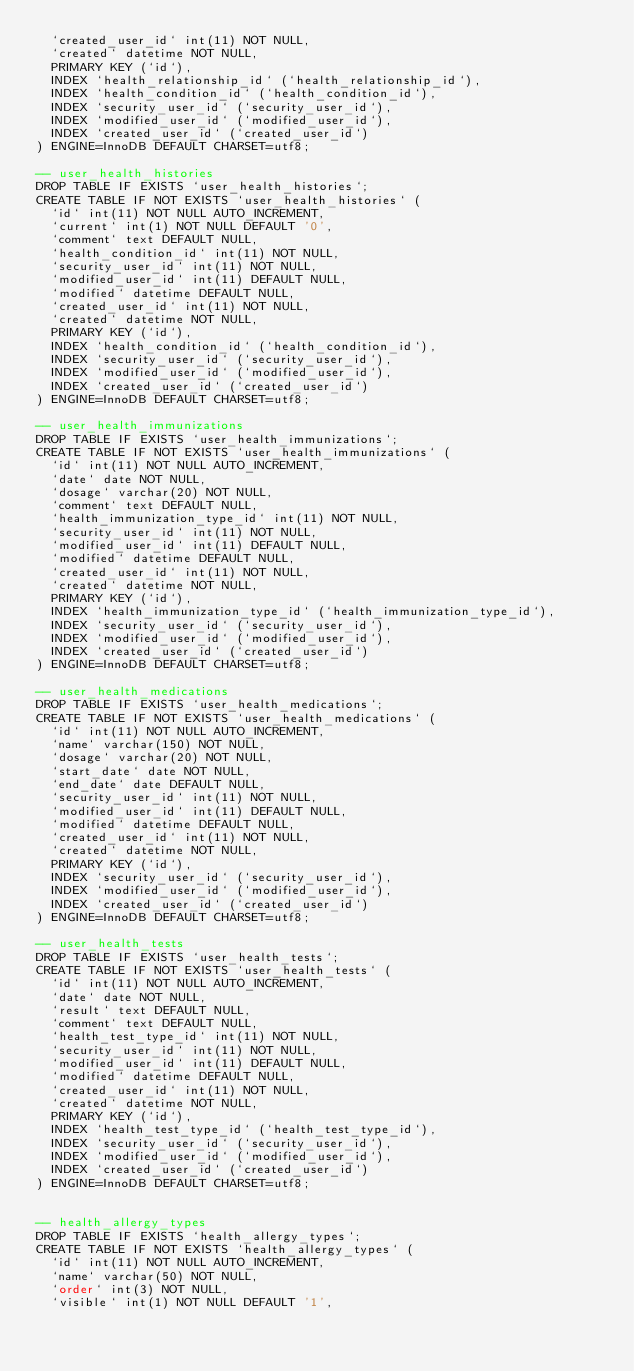<code> <loc_0><loc_0><loc_500><loc_500><_SQL_>  `created_user_id` int(11) NOT NULL,
  `created` datetime NOT NULL,
  PRIMARY KEY (`id`),
  INDEX `health_relationship_id` (`health_relationship_id`),
  INDEX `health_condition_id` (`health_condition_id`),
  INDEX `security_user_id` (`security_user_id`),
  INDEX `modified_user_id` (`modified_user_id`),
  INDEX `created_user_id` (`created_user_id`)
) ENGINE=InnoDB DEFAULT CHARSET=utf8;

-- user_health_histories
DROP TABLE IF EXISTS `user_health_histories`;
CREATE TABLE IF NOT EXISTS `user_health_histories` (
  `id` int(11) NOT NULL AUTO_INCREMENT,
  `current` int(1) NOT NULL DEFAULT '0',
  `comment` text DEFAULT NULL,
  `health_condition_id` int(11) NOT NULL,
  `security_user_id` int(11) NOT NULL,
  `modified_user_id` int(11) DEFAULT NULL,
  `modified` datetime DEFAULT NULL,
  `created_user_id` int(11) NOT NULL,
  `created` datetime NOT NULL,
  PRIMARY KEY (`id`),
  INDEX `health_condition_id` (`health_condition_id`),
  INDEX `security_user_id` (`security_user_id`),
  INDEX `modified_user_id` (`modified_user_id`),
  INDEX `created_user_id` (`created_user_id`)
) ENGINE=InnoDB DEFAULT CHARSET=utf8;

-- user_health_immunizations
DROP TABLE IF EXISTS `user_health_immunizations`;
CREATE TABLE IF NOT EXISTS `user_health_immunizations` (
  `id` int(11) NOT NULL AUTO_INCREMENT,
  `date` date NOT NULL,
  `dosage` varchar(20) NOT NULL,
  `comment` text DEFAULT NULL,  
  `health_immunization_type_id` int(11) NOT NULL,
  `security_user_id` int(11) NOT NULL,
  `modified_user_id` int(11) DEFAULT NULL,
  `modified` datetime DEFAULT NULL,
  `created_user_id` int(11) NOT NULL,
  `created` datetime NOT NULL,
  PRIMARY KEY (`id`),
  INDEX `health_immunization_type_id` (`health_immunization_type_id`),
  INDEX `security_user_id` (`security_user_id`),
  INDEX `modified_user_id` (`modified_user_id`),
  INDEX `created_user_id` (`created_user_id`)
) ENGINE=InnoDB DEFAULT CHARSET=utf8;

-- user_health_medications
DROP TABLE IF EXISTS `user_health_medications`;
CREATE TABLE IF NOT EXISTS `user_health_medications` (
  `id` int(11) NOT NULL AUTO_INCREMENT,
  `name` varchar(150) NOT NULL,
  `dosage` varchar(20) NOT NULL,
  `start_date` date NOT NULL,
  `end_date` date DEFAULT NULL,
  `security_user_id` int(11) NOT NULL,
  `modified_user_id` int(11) DEFAULT NULL,
  `modified` datetime DEFAULT NULL,
  `created_user_id` int(11) NOT NULL,
  `created` datetime NOT NULL,
  PRIMARY KEY (`id`),
  INDEX `security_user_id` (`security_user_id`),
  INDEX `modified_user_id` (`modified_user_id`),
  INDEX `created_user_id` (`created_user_id`)
) ENGINE=InnoDB DEFAULT CHARSET=utf8;

-- user_health_tests
DROP TABLE IF EXISTS `user_health_tests`;
CREATE TABLE IF NOT EXISTS `user_health_tests` (
  `id` int(11) NOT NULL AUTO_INCREMENT,
  `date` date NOT NULL,
  `result` text DEFAULT NULL,
  `comment` text DEFAULT NULL,
  `health_test_type_id` int(11) NOT NULL,
  `security_user_id` int(11) NOT NULL,
  `modified_user_id` int(11) DEFAULT NULL,
  `modified` datetime DEFAULT NULL,
  `created_user_id` int(11) NOT NULL,
  `created` datetime NOT NULL,
  PRIMARY KEY (`id`),
  INDEX `health_test_type_id` (`health_test_type_id`),
  INDEX `security_user_id` (`security_user_id`),
  INDEX `modified_user_id` (`modified_user_id`),
  INDEX `created_user_id` (`created_user_id`)
) ENGINE=InnoDB DEFAULT CHARSET=utf8;


-- health_allergy_types
DROP TABLE IF EXISTS `health_allergy_types`;
CREATE TABLE IF NOT EXISTS `health_allergy_types` (
  `id` int(11) NOT NULL AUTO_INCREMENT,
  `name` varchar(50) NOT NULL,
  `order` int(3) NOT NULL,
  `visible` int(1) NOT NULL DEFAULT '1',</code> 